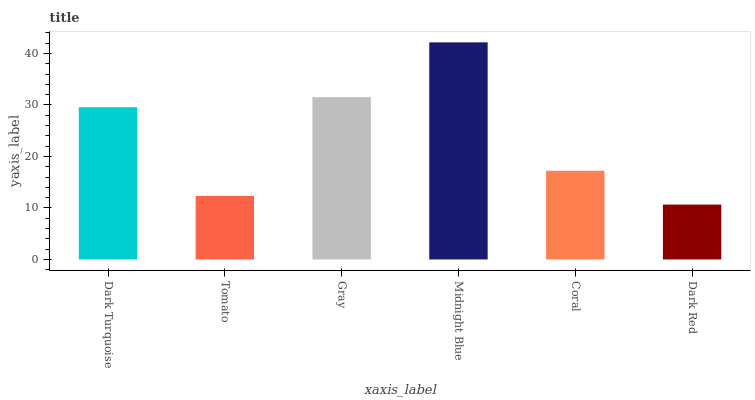Is Dark Red the minimum?
Answer yes or no. Yes. Is Midnight Blue the maximum?
Answer yes or no. Yes. Is Tomato the minimum?
Answer yes or no. No. Is Tomato the maximum?
Answer yes or no. No. Is Dark Turquoise greater than Tomato?
Answer yes or no. Yes. Is Tomato less than Dark Turquoise?
Answer yes or no. Yes. Is Tomato greater than Dark Turquoise?
Answer yes or no. No. Is Dark Turquoise less than Tomato?
Answer yes or no. No. Is Dark Turquoise the high median?
Answer yes or no. Yes. Is Coral the low median?
Answer yes or no. Yes. Is Midnight Blue the high median?
Answer yes or no. No. Is Dark Turquoise the low median?
Answer yes or no. No. 